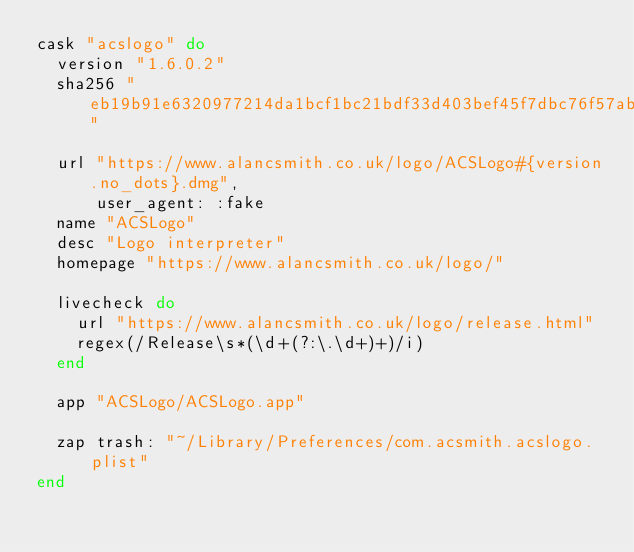Convert code to text. <code><loc_0><loc_0><loc_500><loc_500><_Ruby_>cask "acslogo" do
  version "1.6.0.2"
  sha256 "eb19b91e6320977214da1bcf1bc21bdf33d403bef45f7dbc76f57abc5337cc76"

  url "https://www.alancsmith.co.uk/logo/ACSLogo#{version.no_dots}.dmg",
      user_agent: :fake
  name "ACSLogo"
  desc "Logo interpreter"
  homepage "https://www.alancsmith.co.uk/logo/"

  livecheck do
    url "https://www.alancsmith.co.uk/logo/release.html"
    regex(/Release\s*(\d+(?:\.\d+)+)/i)
  end

  app "ACSLogo/ACSLogo.app"

  zap trash: "~/Library/Preferences/com.acsmith.acslogo.plist"
end
</code> 